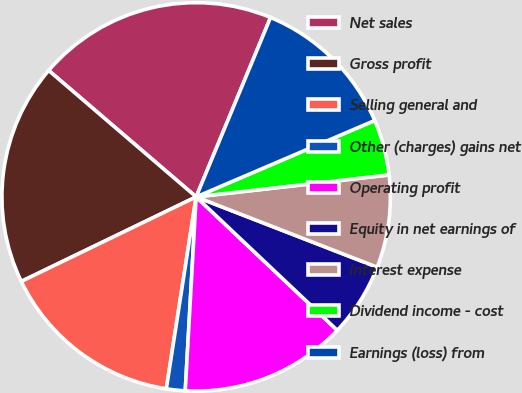Convert chart to OTSL. <chart><loc_0><loc_0><loc_500><loc_500><pie_chart><fcel>Net sales<fcel>Gross profit<fcel>Selling general and<fcel>Other (charges) gains net<fcel>Operating profit<fcel>Equity in net earnings of<fcel>Interest expense<fcel>Dividend income - cost<fcel>Earnings (loss) from<nl><fcel>19.98%<fcel>18.45%<fcel>15.38%<fcel>1.56%<fcel>13.84%<fcel>6.16%<fcel>7.7%<fcel>4.63%<fcel>12.31%<nl></chart> 